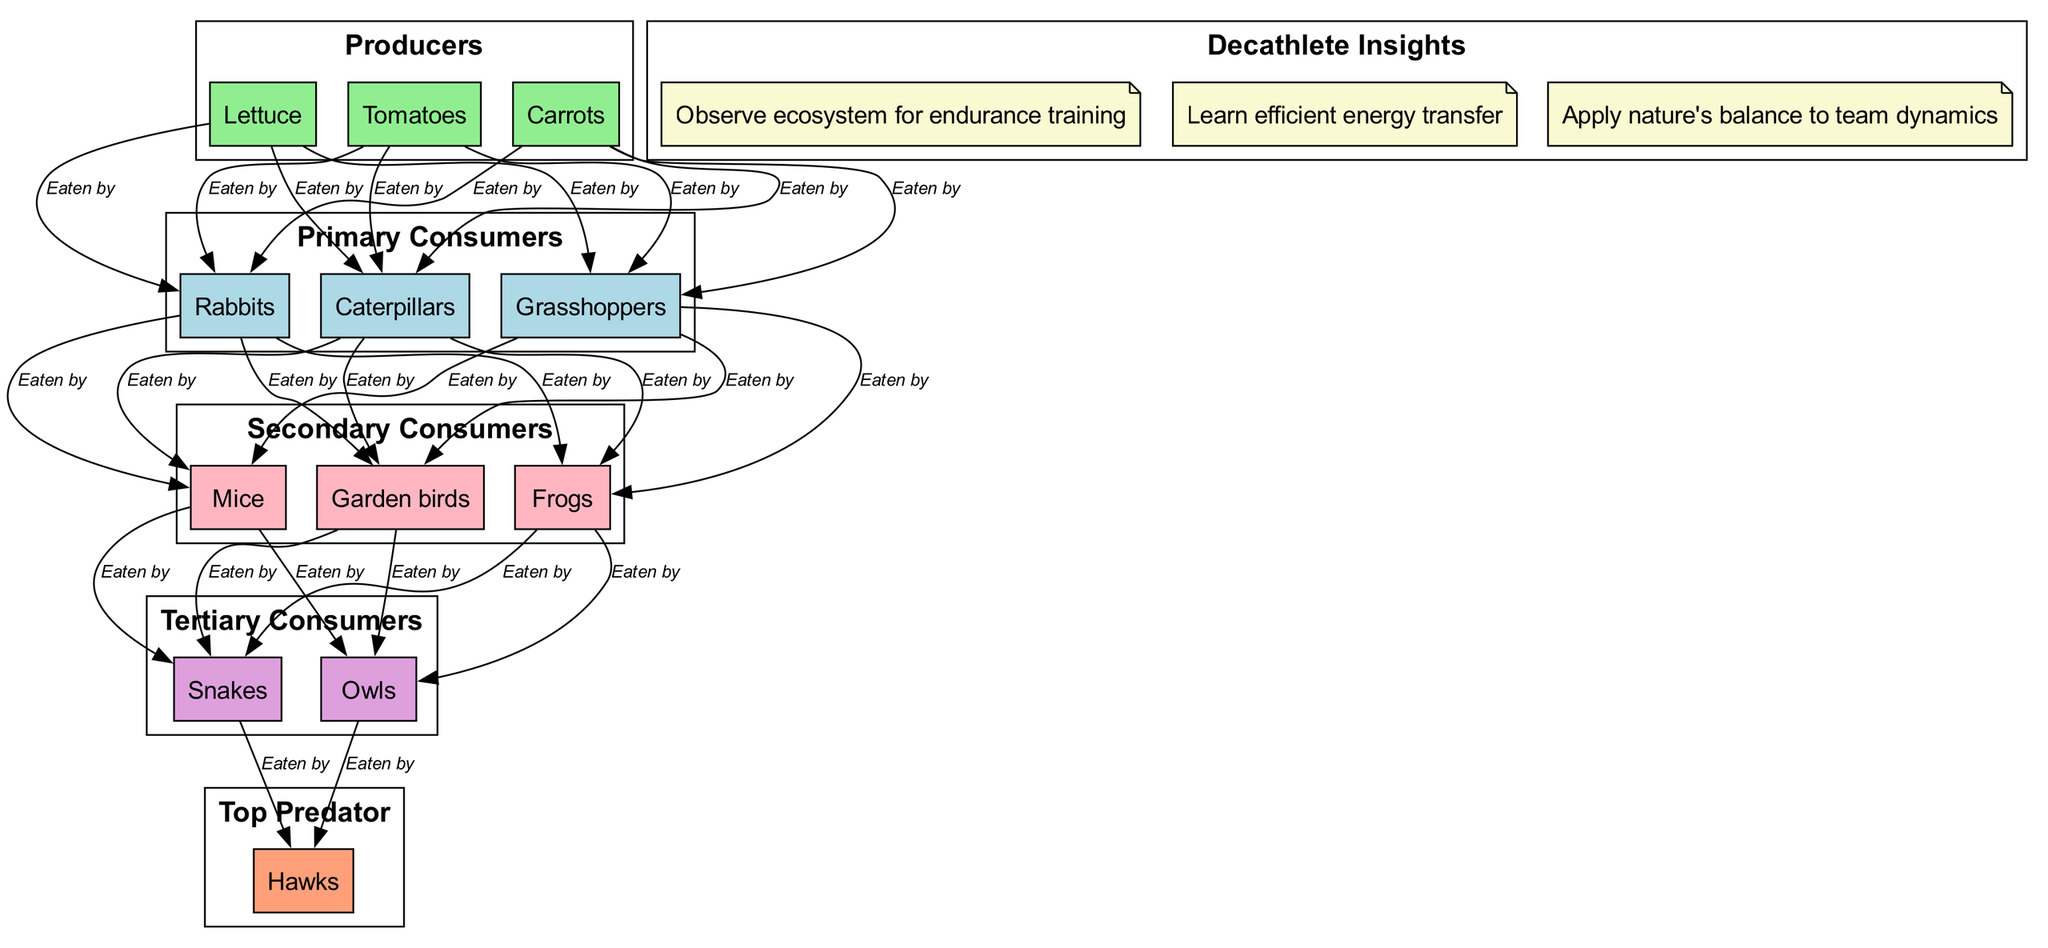What are the producers in this ecosystem? The producers are the first level of the food chain, which provide energy to the consumers. According to the diagram, the producers listed are Lettuce, Tomatoes, and Carrots.
Answer: Lettuce, Tomatoes, Carrots How many primary consumers are there? The primary consumers are the second level in the food chain. By counting the items listed, we see there are three primary consumers: Rabbits, Grasshoppers, and Caterpillars.
Answer: 3 What do frogs eat? In the food chain, frogs are categorized as secondary consumers, which means they eat primary consumers. According to the diagram, the primary consumers are Rabbits, Grasshoppers, and Caterpillars. Therefore, frogs eat these organisms.
Answer: Rabbits, Grasshoppers, Caterpillars Which level comes before the top predator? The top predator in this diagram is Hawks, and they are at the top of the food chain. The level before the top predator is tertiary consumers, which include Snakes and Owls.
Answer: Tertiary consumers How many relationships are represented in the diagram? The relationships in the diagram describe how one organism provides energy to another or is eaten by another. The diagram identifies a flow from producers to primary consumers, then to secondary, tertiary, and finally to the top predator. By counting the relationships connecting these levels, we find there are 9 relationships represented (3 from producers to primary consumers, 3 from primary to secondary, 2 from secondary to tertiary, and 1 from tertiary to top predator).
Answer: 9 Which organism has no known predators in this ecosystem? In the diagram, the top predator is Hawks, which signifies they have no natural predators in this ecosystem, as they sit at the top of the food chain. Therefore, Hawks are their own group with no predators.
Answer: Hawks What insights can a decathlete gain from observing this ecosystem? The diagram highlights several insights that a decathlete can gain, such as the observation of how energy is transferred within the ecosystem, endurance training insights from the balance and interactions among species, and how these natural dynamics apply to team dynamics in sports training.
Answer: Observe ecosystem for endurance training, Learn efficient energy transfer, Apply nature's balance to team dynamics Which group provides energy to primary consumers? Primary consumers in the food chain rely on the producers for energy. Therefore, we look back one level and see that the producers—Lettuce, Tomatoes, and Carrots—provide energy to primary consumers.
Answer: Lettuce, Tomatoes, Carrots 